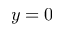<formula> <loc_0><loc_0><loc_500><loc_500>y = 0</formula> 